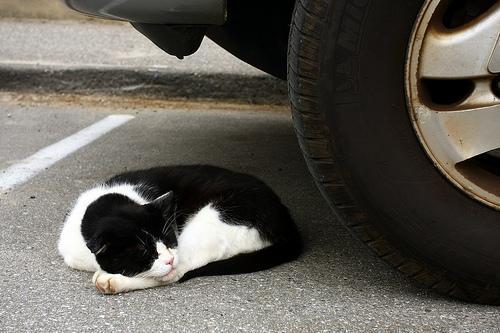How many animals are shown?
Give a very brief answer. 1. 